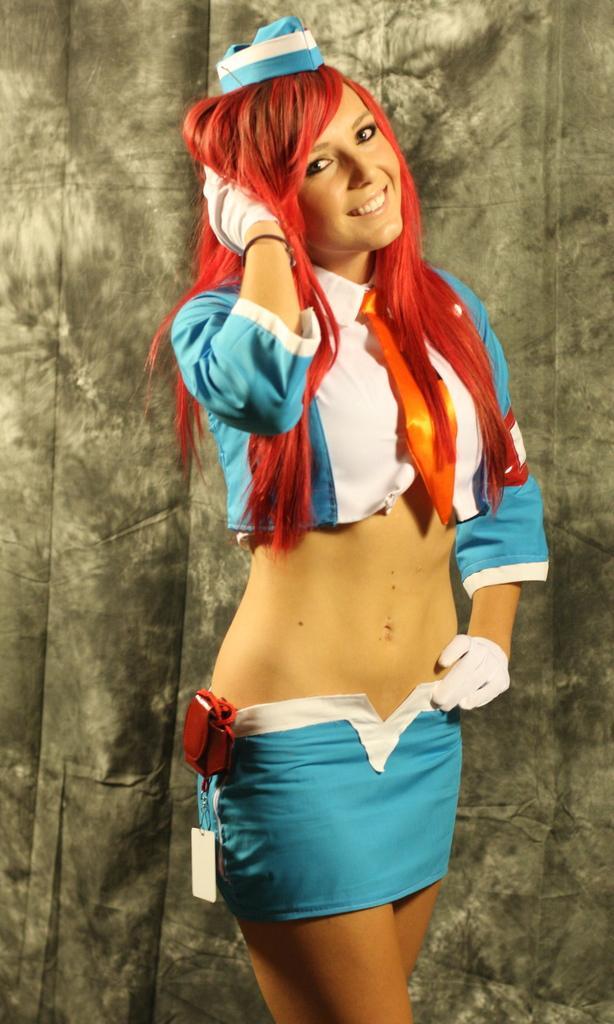Please provide a concise description of this image. In the center of the image there is a woman with red hat and she is smiling. In the background there is cloth. 